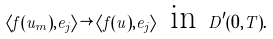Convert formula to latex. <formula><loc_0><loc_0><loc_500><loc_500>\left \langle f ( u _ { m } ) , e _ { j } \right \rangle \rightarrow \left \langle f ( u ) , e _ { j } \right \rangle \text { in\ } D ^ { \prime } ( 0 , T ) .</formula> 